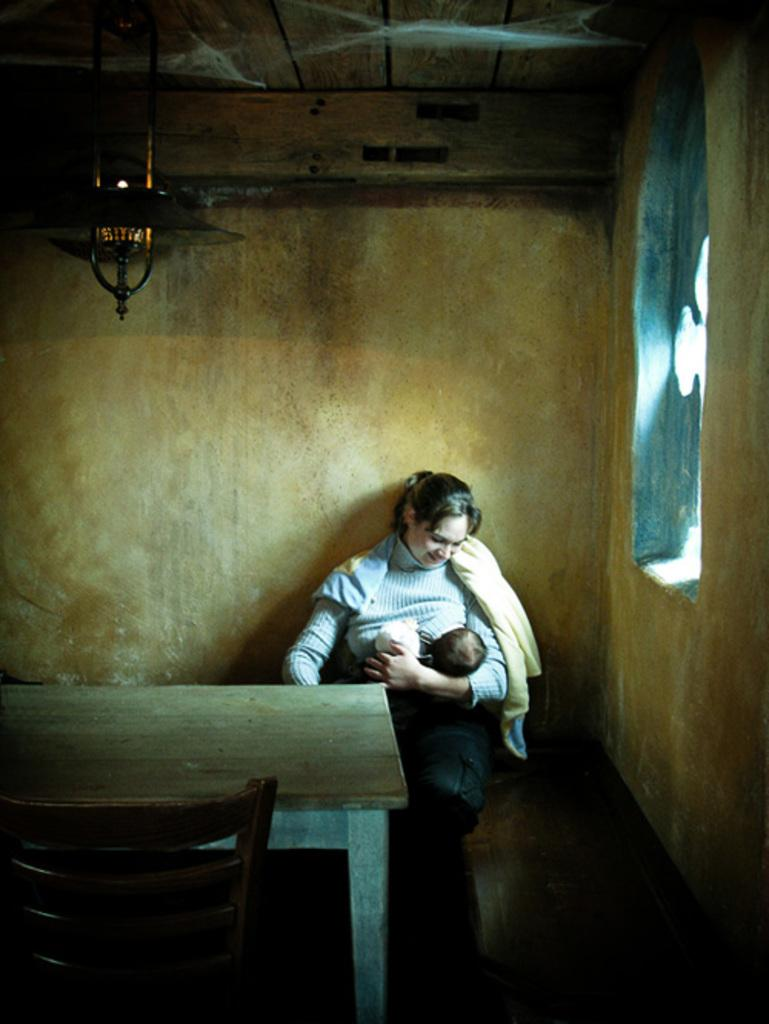Who is the main subject in the image? There is a woman in the image. What is the woman doing in the image? The woman is breastfeeding her baby. Where is the woman sitting in the room? The woman is sitting at a corner of the room. Are there any bookshelves or a library visible in the image? There is no mention of bookshelves or a library in the image; it features a woman breastfeeding her baby while sitting at a corner of the room. 